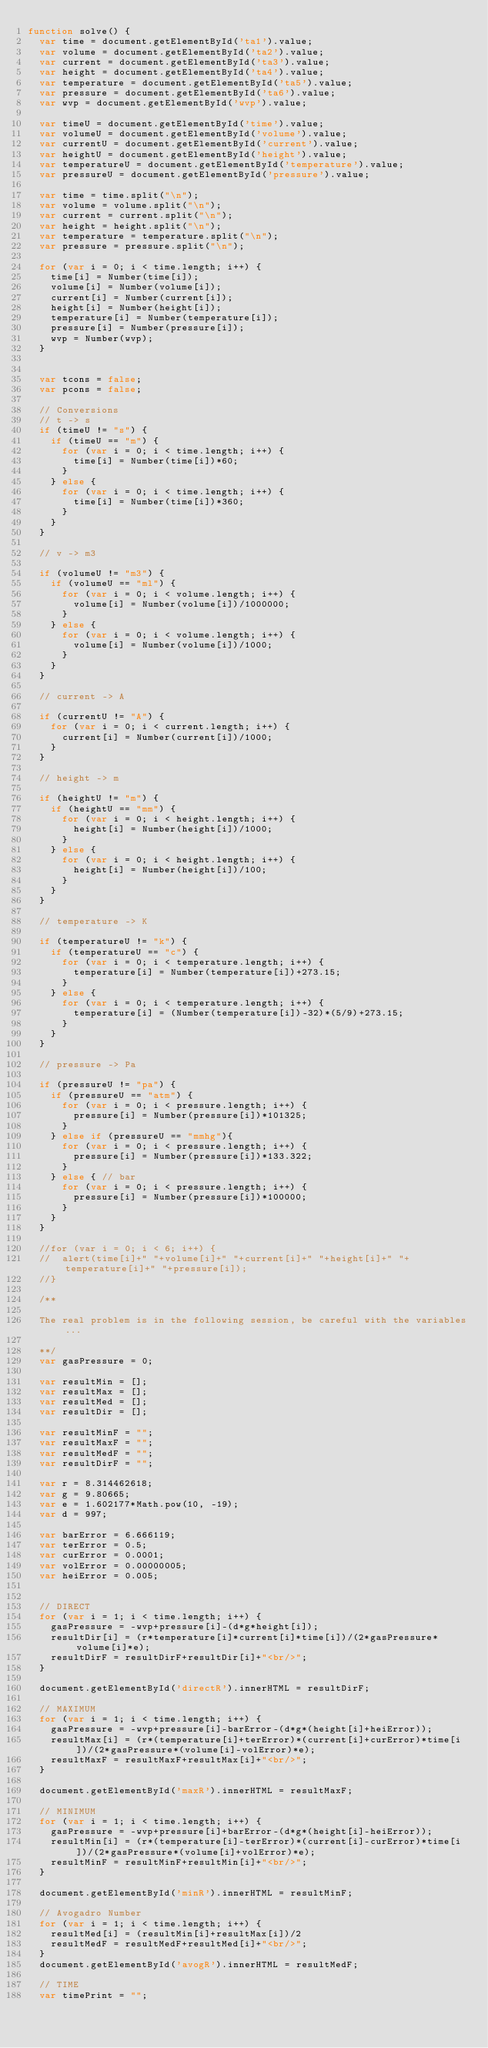<code> <loc_0><loc_0><loc_500><loc_500><_JavaScript_>function solve() {
	var time = document.getElementById('ta1').value;
	var volume = document.getElementById('ta2').value;
	var current = document.getElementById('ta3').value;
	var height = document.getElementById('ta4').value;
	var temperature = document.getElementById('ta5').value;
	var pressure = document.getElementById('ta6').value;
	var wvp = document.getElementById('wvp').value;

	var timeU = document.getElementById('time').value;
	var volumeU = document.getElementById('volume').value;
	var currentU = document.getElementById('current').value;
	var heightU = document.getElementById('height').value;
	var temperatureU = document.getElementById('temperature').value;
	var pressureU = document.getElementById('pressure').value;

	var time = time.split("\n");
	var volume = volume.split("\n");
	var current = current.split("\n");
	var height = height.split("\n");
	var temperature = temperature.split("\n");
	var pressure = pressure.split("\n");

	for (var i = 0; i < time.length; i++) {
		time[i] = Number(time[i]);
		volume[i] = Number(volume[i]);
		current[i] = Number(current[i]);
		height[i] = Number(height[i]);
		temperature[i] = Number(temperature[i]);
		pressure[i] = Number(pressure[i]);
		wvp = Number(wvp);
	}


	var tcons = false;
	var pcons = false;

	// Conversions
	// t -> s
	if (timeU != "s") {
		if (timeU == "m") {
			for (var i = 0; i < time.length; i++) {
				time[i] = Number(time[i])*60;
			}
		} else {
			for (var i = 0; i < time.length; i++) {
				time[i] = Number(time[i])*360;
			}
		}
	}

	// v -> m3

	if (volumeU != "m3") {
		if (volumeU == "ml") {
			for (var i = 0; i < volume.length; i++) {
				volume[i] = Number(volume[i])/1000000;
			}
		} else {
			for (var i = 0; i < volume.length; i++) {
				volume[i] = Number(volume[i])/1000;
			}
		}
	}

	// current -> A

	if (currentU != "A") {
		for (var i = 0; i < current.length; i++) {
			current[i] = Number(current[i])/1000;
		}
	}

	// height -> m

	if (heightU != "m") {
		if (heightU == "mm") {
			for (var i = 0; i < height.length; i++) {
				height[i] = Number(height[i])/1000;
			}
		} else {
			for (var i = 0; i < height.length; i++) {
				height[i] = Number(height[i])/100;
			}
		}
	}

	// temperature -> K

	if (temperatureU != "k") {
		if (temperatureU == "c") {
			for (var i = 0; i < temperature.length; i++) {
				temperature[i] = Number(temperature[i])+273.15;
			}
		} else {
			for (var i = 0; i < temperature.length; i++) {
				temperature[i] = (Number(temperature[i])-32)*(5/9)+273.15;
			}
		}
	}

	// pressure -> Pa

	if (pressureU != "pa") {
		if (pressureU == "atm") {
			for (var i = 0; i < pressure.length; i++) {
				pressure[i] = Number(pressure[i])*101325;
			}
		} else if (pressureU == "mmhg"){
			for (var i = 0; i < pressure.length; i++) {
				pressure[i] = Number(pressure[i])*133.322;
			}
		} else { // bar
			for (var i = 0; i < pressure.length; i++) {
				pressure[i] = Number(pressure[i])*100000;
			}
		}
	}

	//for (var i = 0; i < 6; i++) {
	//	alert(time[i]+" "+volume[i]+" "+current[i]+" "+height[i]+" "+temperature[i]+" "+pressure[i]);
	//}

	/**

	The real problem is in the following session, be careful with the variables...

	**/
	var gasPressure = 0;

	var resultMin = [];
	var resultMax = [];
	var resultMed = [];
	var resultDir = [];

	var resultMinF = "";
	var resultMaxF = "";
	var resultMedF = "";
	var resultDirF = "";

	var r = 8.314462618;
	var g = 9.80665;
	var e = 1.602177*Math.pow(10, -19);
	var d = 997;

	var barError = 6.666119;
	var terError = 0.5;
	var curError = 0.0001;
	var volError = 0.00000005;
	var heiError = 0.005;


	// DIRECT
	for (var i = 1; i < time.length; i++) {
		gasPressure = -wvp+pressure[i]-(d*g*height[i]);
		resultDir[i] = (r*temperature[i]*current[i]*time[i])/(2*gasPressure*volume[i]*e);
		resultDirF = resultDirF+resultDir[i]+"<br/>";
	}

	document.getElementById('directR').innerHTML = resultDirF;

	// MAXIMUM
	for (var i = 1; i < time.length; i++) {
		gasPressure = -wvp+pressure[i]-barError-(d*g*(height[i]+heiError));
		resultMax[i] = (r*(temperature[i]+terError)*(current[i]+curError)*time[i])/(2*gasPressure*(volume[i]-volError)*e);
		resultMaxF = resultMaxF+resultMax[i]+"<br/>";
	}

	document.getElementById('maxR').innerHTML = resultMaxF;

	// MINIMUM
	for (var i = 1; i < time.length; i++) {
		gasPressure = -wvp+pressure[i]+barError-(d*g*(height[i]-heiError));
		resultMin[i] = (r*(temperature[i]-terError)*(current[i]-curError)*time[i])/(2*gasPressure*(volume[i]+volError)*e);
		resultMinF = resultMinF+resultMin[i]+"<br/>";
	}

	document.getElementById('minR').innerHTML = resultMinF;

	// Avogadro Number
	for (var i = 1; i < time.length; i++) {
		resultMed[i] = (resultMin[i]+resultMax[i])/2
		resultMedF = resultMedF+resultMed[i]+"<br/>";
	}
	document.getElementById('avogR').innerHTML = resultMedF;

	// TIME
	var timePrint = "";</code> 